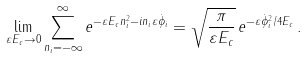Convert formula to latex. <formula><loc_0><loc_0><loc_500><loc_500>\lim _ { \varepsilon E _ { c } \rightarrow 0 } \sum _ { n _ { i } = - \infty } ^ { \infty } e ^ { - \varepsilon E _ { c } n _ { i } ^ { 2 } - i n _ { i } \varepsilon \dot { \phi } _ { i } } = \sqrt { \frac { \pi } { \varepsilon E _ { c } } } \, e ^ { - \varepsilon \dot { \phi } _ { i } ^ { 2 } / 4 E _ { c } } \, .</formula> 